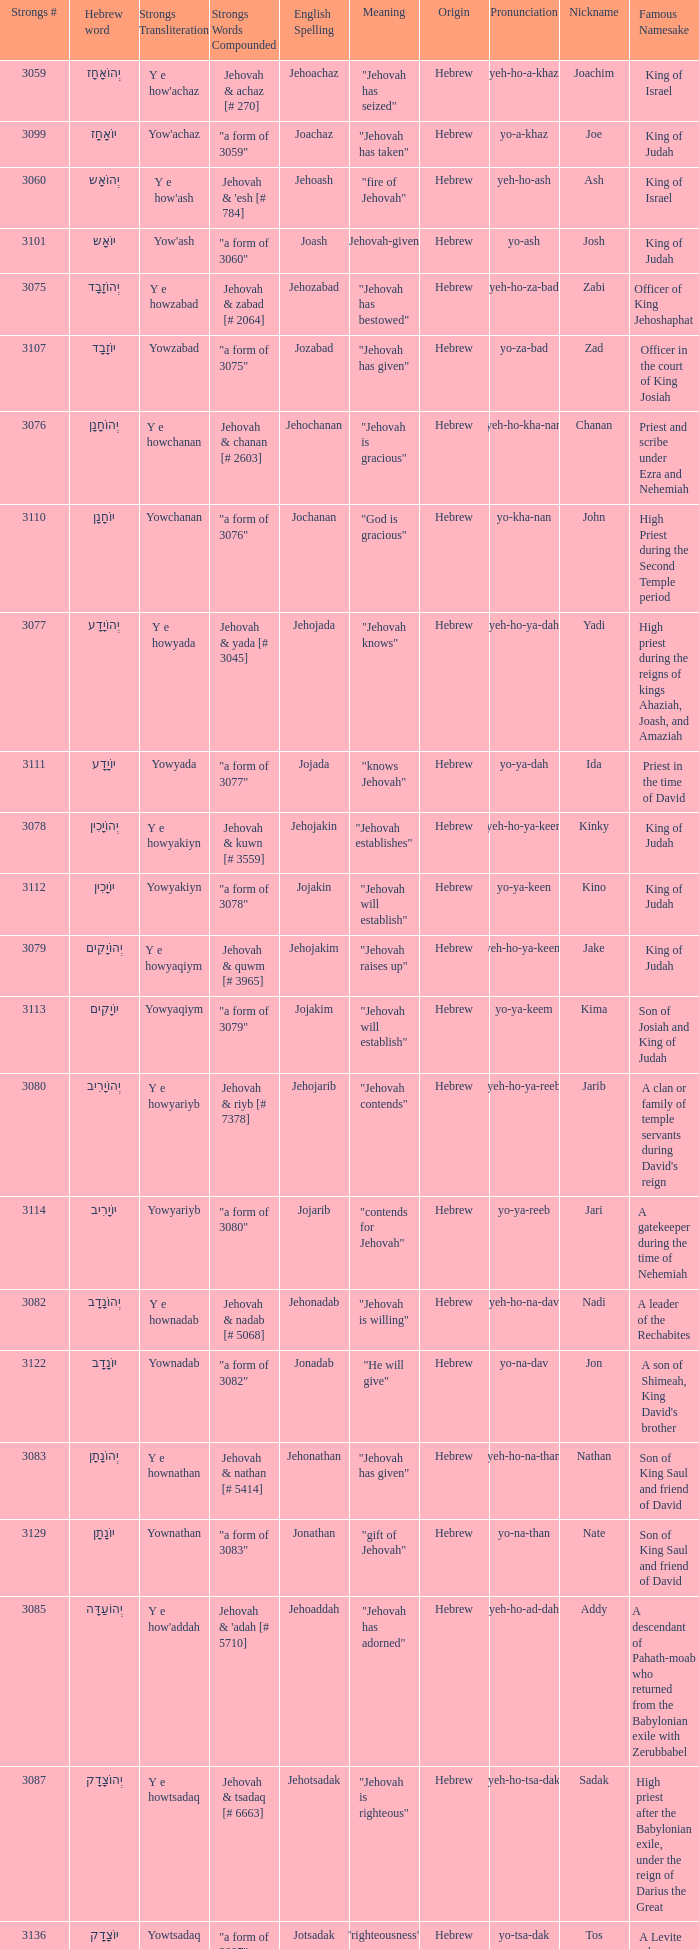How many strongs transliteration of the english spelling of the work jehojakin? 1.0. 